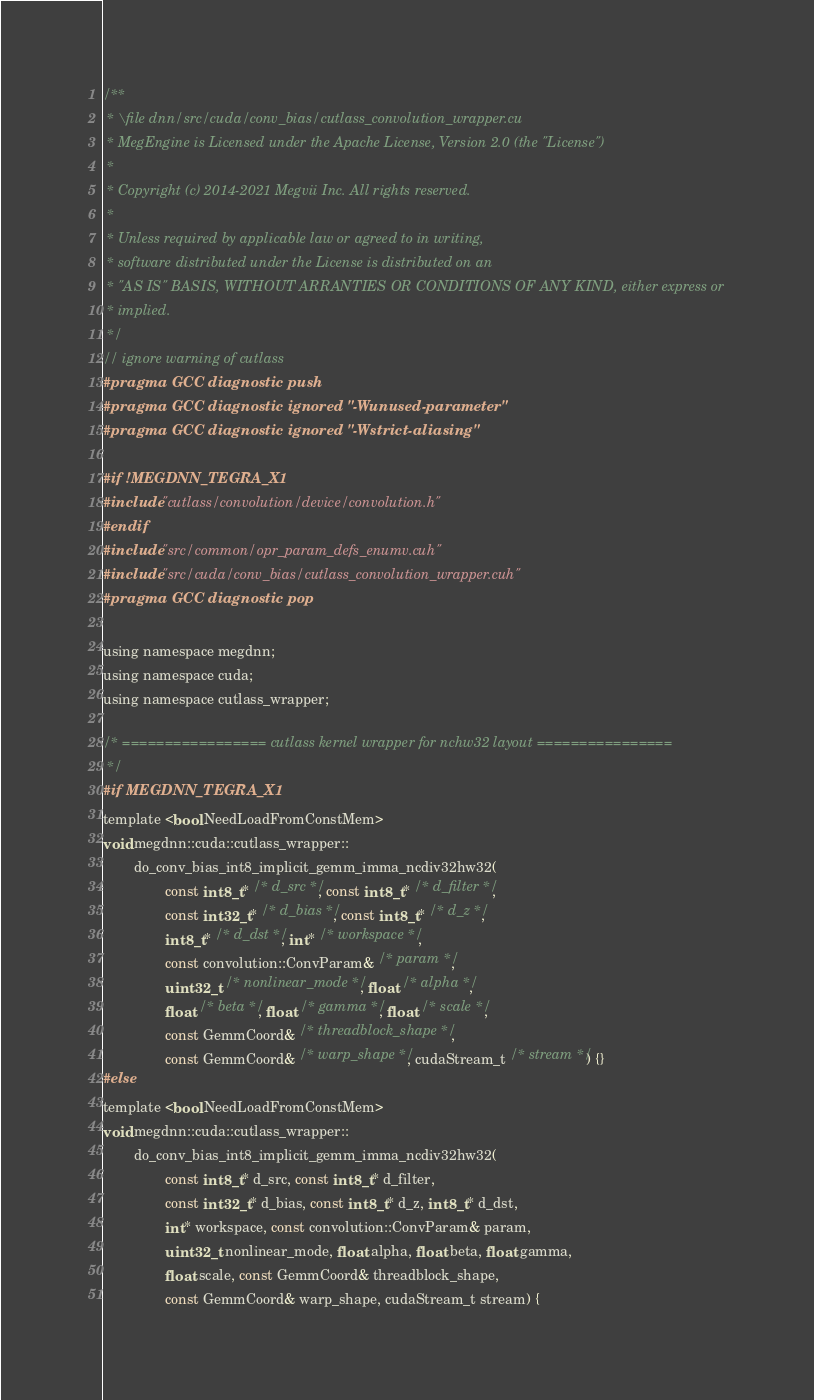<code> <loc_0><loc_0><loc_500><loc_500><_Cuda_>/**
 * \file dnn/src/cuda/conv_bias/cutlass_convolution_wrapper.cu
 * MegEngine is Licensed under the Apache License, Version 2.0 (the "License")
 *
 * Copyright (c) 2014-2021 Megvii Inc. All rights reserved.
 *
 * Unless required by applicable law or agreed to in writing,
 * software distributed under the License is distributed on an
 * "AS IS" BASIS, WITHOUT ARRANTIES OR CONDITIONS OF ANY KIND, either express or
 * implied.
 */
// ignore warning of cutlass
#pragma GCC diagnostic push
#pragma GCC diagnostic ignored "-Wunused-parameter"
#pragma GCC diagnostic ignored "-Wstrict-aliasing"

#if !MEGDNN_TEGRA_X1
#include "cutlass/convolution/device/convolution.h"
#endif
#include "src/common/opr_param_defs_enumv.cuh"
#include "src/cuda/conv_bias/cutlass_convolution_wrapper.cuh"
#pragma GCC diagnostic pop

using namespace megdnn;
using namespace cuda;
using namespace cutlass_wrapper;

/* ================= cutlass kernel wrapper for nchw32 layout ================
 */
#if MEGDNN_TEGRA_X1
template <bool NeedLoadFromConstMem>
void megdnn::cuda::cutlass_wrapper::
        do_conv_bias_int8_implicit_gemm_imma_ncdiv32hw32(
                const int8_t* /* d_src */, const int8_t* /* d_filter */,
                const int32_t* /* d_bias */, const int8_t* /* d_z */,
                int8_t* /* d_dst */, int* /* workspace */,
                const convolution::ConvParam& /* param */,
                uint32_t /* nonlinear_mode */, float /* alpha */,
                float /* beta */, float /* gamma */, float /* scale */,
                const GemmCoord& /* threadblock_shape */,
                const GemmCoord& /* warp_shape */, cudaStream_t /* stream */) {}
#else
template <bool NeedLoadFromConstMem>
void megdnn::cuda::cutlass_wrapper::
        do_conv_bias_int8_implicit_gemm_imma_ncdiv32hw32(
                const int8_t* d_src, const int8_t* d_filter,
                const int32_t* d_bias, const int8_t* d_z, int8_t* d_dst,
                int* workspace, const convolution::ConvParam& param,
                uint32_t nonlinear_mode, float alpha, float beta, float gamma,
                float scale, const GemmCoord& threadblock_shape,
                const GemmCoord& warp_shape, cudaStream_t stream) {</code> 